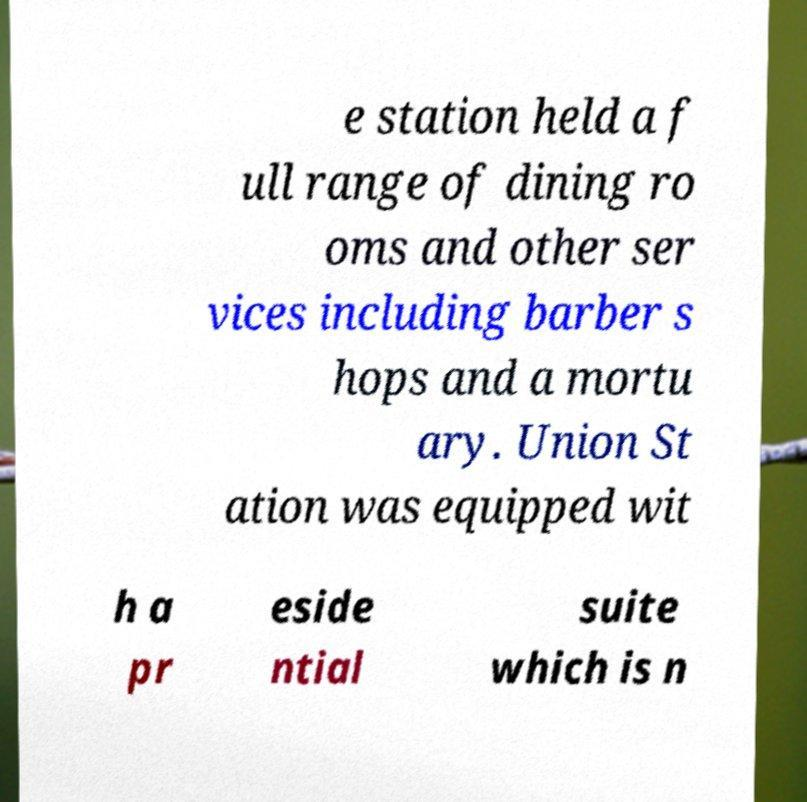Can you accurately transcribe the text from the provided image for me? e station held a f ull range of dining ro oms and other ser vices including barber s hops and a mortu ary. Union St ation was equipped wit h a pr eside ntial suite which is n 